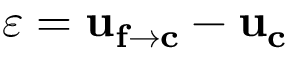<formula> <loc_0><loc_0><loc_500><loc_500>\varepsilon = u _ { f \rightarrow c } - u _ { c }</formula> 